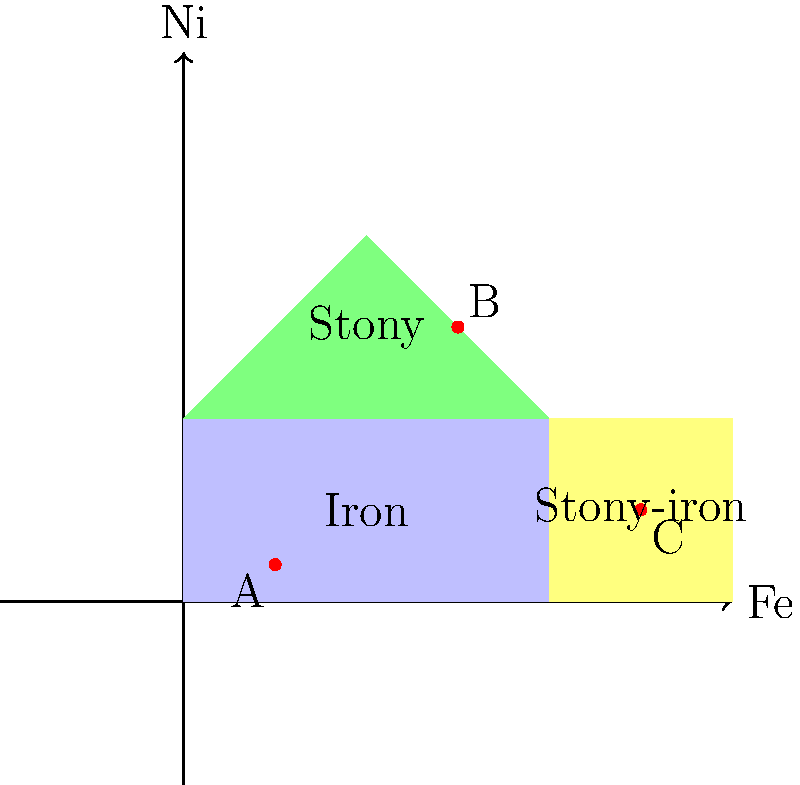The diagram above shows a simplified classification of meteorites based on their iron (Fe) and nickel (Ni) content. Points A, B, and C represent different meteorite samples. Which of these samples is most likely to exhibit a hexagonal close-packed (HCP) crystal structure in its metal phases? To answer this question, we need to consider the relationship between composition and crystal structure in meteorites:

1. Iron meteorites (region containing point A) are primarily composed of iron-nickel alloys.
2. Stony meteorites (region containing point B) have a lower metal content and are mainly composed of silicate minerals.
3. Stony-iron meteorites (region containing point C) have a mixture of metal and silicate phases.

The crystal structure of metal phases in meteorites depends on their composition:

4. Pure iron at room temperature has a body-centered cubic (BCC) structure.
5. As nickel content increases, the crystal structure can change to face-centered cubic (FCC) or hexagonal close-packed (HCP).
6. The HCP structure is typically observed in iron-nickel alloys with nickel content between 5-20%.

Analyzing the points:
7. Point A (iron meteorite): Low nickel content, likely BCC or FCC structure.
8. Point B (stony meteorite): High nickel content relative to iron, but overall low metal content.
9. Point C (stony-iron meteorite): Moderate nickel content, falling within the range where HCP structure is likely to form.

Therefore, the sample most likely to exhibit an HCP crystal structure in its metal phases is point C, representing a stony-iron meteorite.
Answer: C (stony-iron meteorite) 